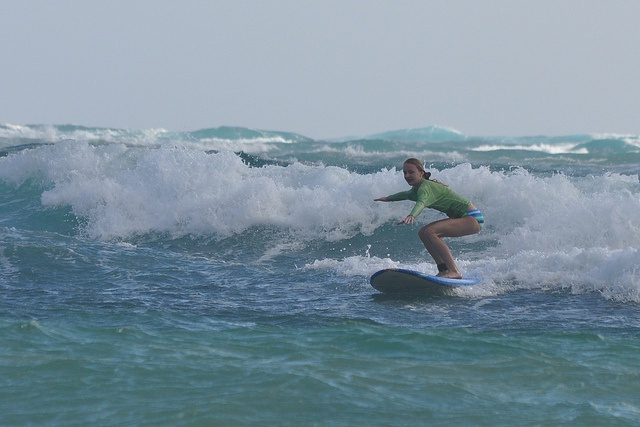Describe the objects in this image and their specific colors. I can see people in darkgray, gray, black, and teal tones and surfboard in darkgray, darkblue, and gray tones in this image. 